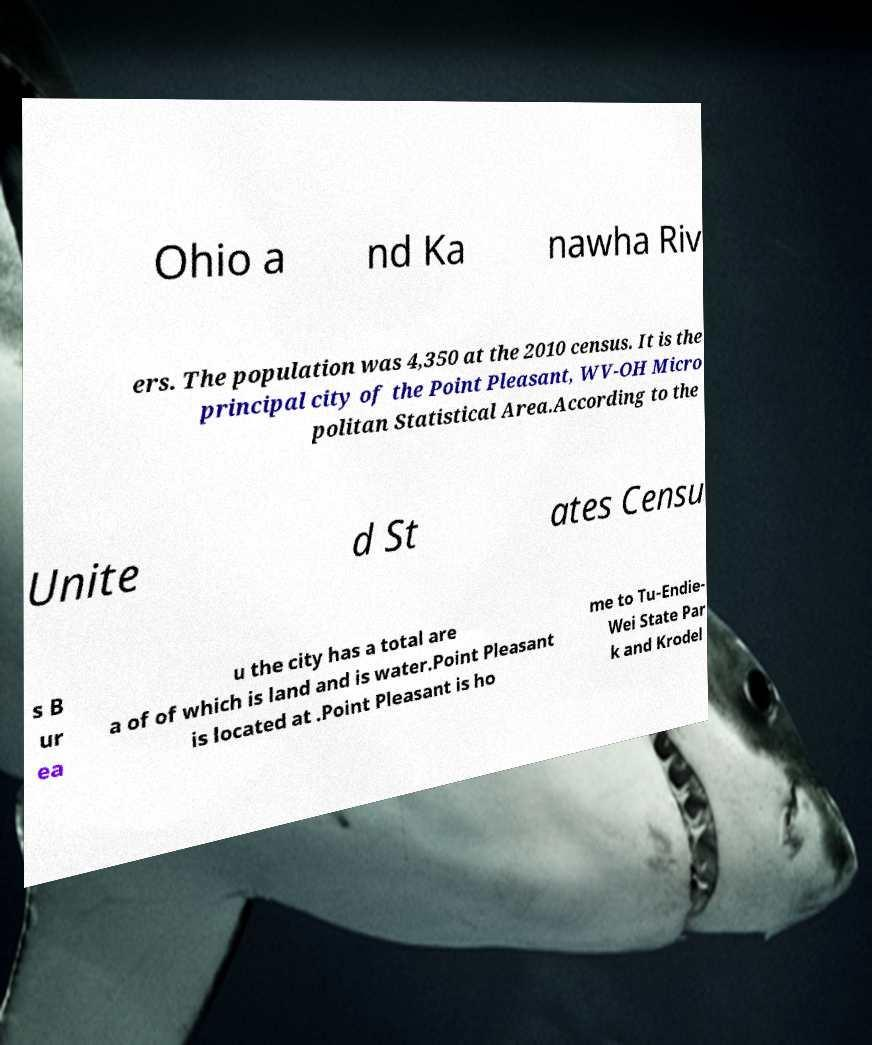I need the written content from this picture converted into text. Can you do that? Ohio a nd Ka nawha Riv ers. The population was 4,350 at the 2010 census. It is the principal city of the Point Pleasant, WV-OH Micro politan Statistical Area.According to the Unite d St ates Censu s B ur ea u the city has a total are a of of which is land and is water.Point Pleasant is located at .Point Pleasant is ho me to Tu-Endie- Wei State Par k and Krodel 